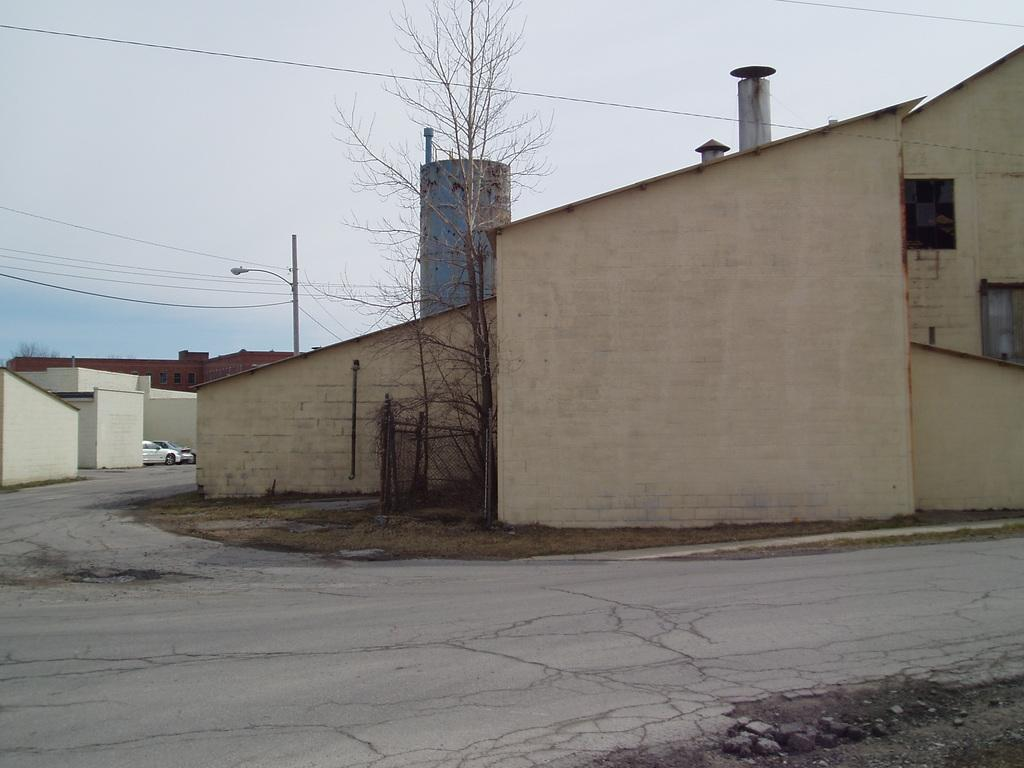What type of structures can be seen in the image? There are buildings in the image. What else can be seen in the image besides buildings? There are poles, electric wires, a road, grass, a tree, and vehicles in the image. Can you describe the road in the image? The road is visible in the image. What is the natural element present in the image? There is grass in the image. What else can be seen in the sky in the image? The sky is visible in the image. What type of feast is being held under the tree in the image? There is no feast present in the image; it only shows buildings, poles, electric wires, a road, grass, a tree, vehicles, and the sky. What type of lock is securing the buildings in the image? There is no lock present in the image; it only shows buildings, poles, electric wires, a road, grass, a tree, vehicles, and the sky. 